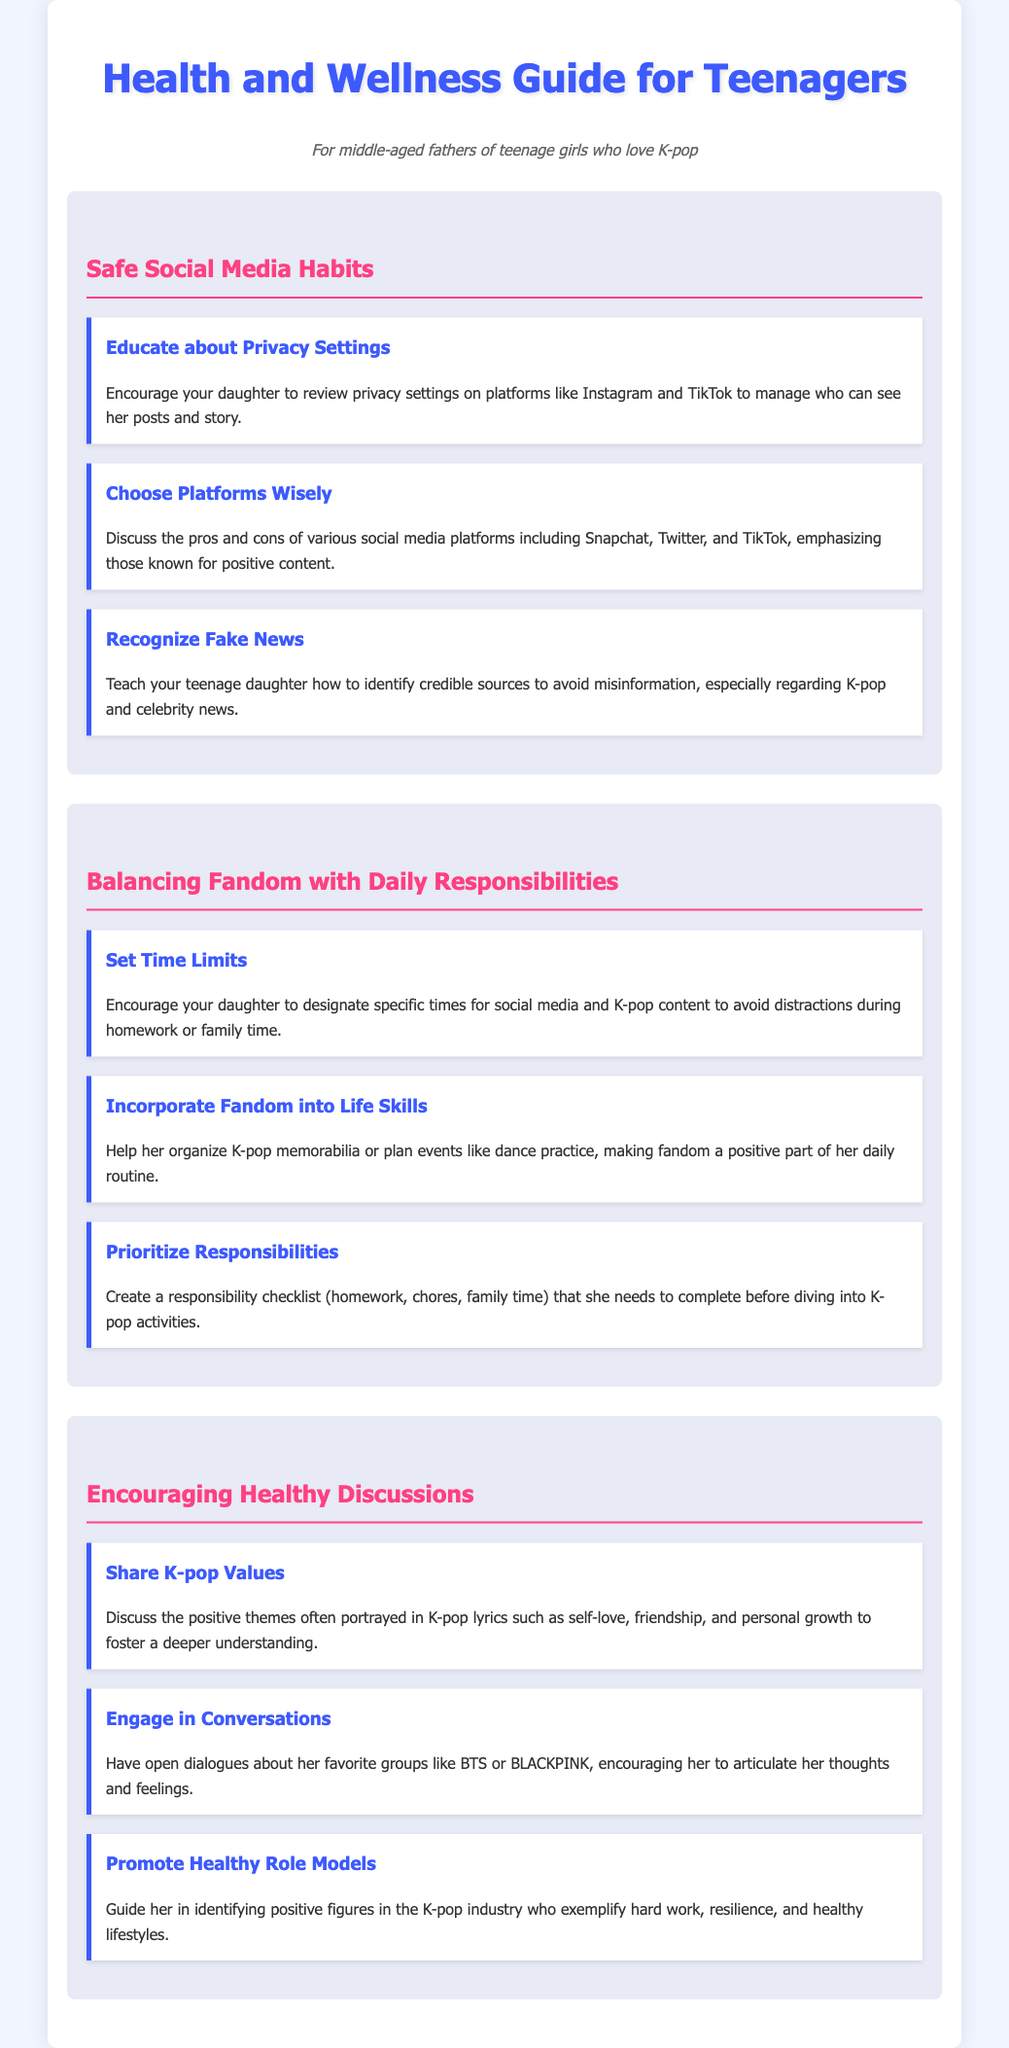What are the social media platforms mentioned? The document lists specific social media platforms known for positive content like Instagram, TikTok, Snapchat, and Twitter.
Answer: Instagram, TikTok, Snapchat, Twitter What is one way to manage time for social media? The document suggests encouraging the daughter to designate specific times for social media and K-pop content to avoid distractions.
Answer: Set time limits What should teenage girls recognize to avoid misinformation? The document advises teaching teenage girls how to identify credible sources to avoid misinformation.
Answer: Fake news What is a key theme in K-pop lyrics mentioned? The document highlights self-love as a positive theme often portrayed in K-pop lyrics.
Answer: Self-love What is suggested to incorporate fandom into daily routines? The document recommends helping organize K-pop memorabilia or planning events like dance practice.
Answer: Incorporate fandom into life skills What is one aspect of healthy discussions mentioned? The document emphasizes sharing K-pop values, such as friendship and personal growth, to encourage dialogue.
Answer: Share K-pop values How should responsibilities be prioritized according to the guide? The document suggests creating a responsibility checklist of homework, chores, and family time.
Answer: Prioritize responsibilities 